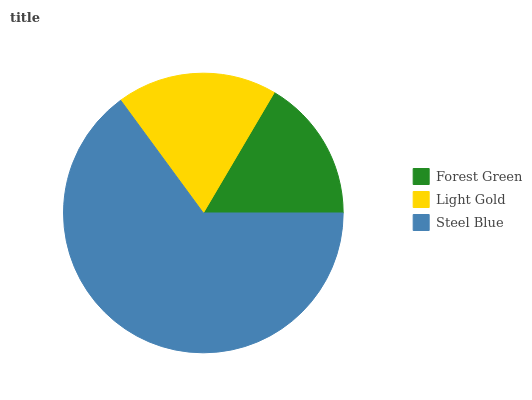Is Forest Green the minimum?
Answer yes or no. Yes. Is Steel Blue the maximum?
Answer yes or no. Yes. Is Light Gold the minimum?
Answer yes or no. No. Is Light Gold the maximum?
Answer yes or no. No. Is Light Gold greater than Forest Green?
Answer yes or no. Yes. Is Forest Green less than Light Gold?
Answer yes or no. Yes. Is Forest Green greater than Light Gold?
Answer yes or no. No. Is Light Gold less than Forest Green?
Answer yes or no. No. Is Light Gold the high median?
Answer yes or no. Yes. Is Light Gold the low median?
Answer yes or no. Yes. Is Forest Green the high median?
Answer yes or no. No. Is Forest Green the low median?
Answer yes or no. No. 